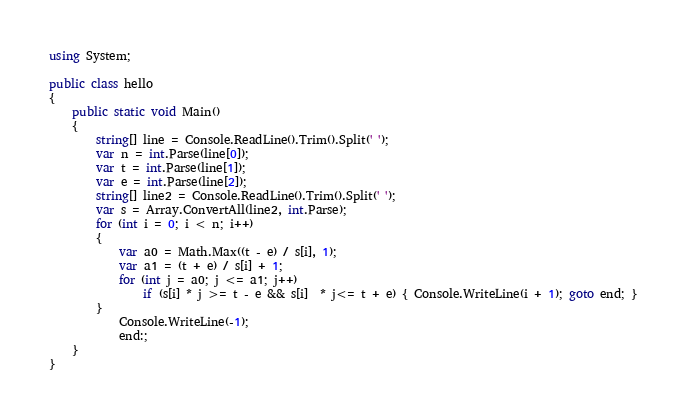Convert code to text. <code><loc_0><loc_0><loc_500><loc_500><_C#_>using System;

public class hello
{
    public static void Main()
    {
        string[] line = Console.ReadLine().Trim().Split(' ');
        var n = int.Parse(line[0]);
        var t = int.Parse(line[1]);
        var e = int.Parse(line[2]);
        string[] line2 = Console.ReadLine().Trim().Split(' ');
        var s = Array.ConvertAll(line2, int.Parse);
        for (int i = 0; i < n; i++)
        {
            var a0 = Math.Max((t - e) / s[i], 1);
            var a1 = (t + e) / s[i] + 1;
            for (int j = a0; j <= a1; j++)
                if (s[i] * j >= t - e && s[i]  * j<= t + e) { Console.WriteLine(i + 1); goto end; }
        }
            Console.WriteLine(-1);
            end:;
    }
}</code> 